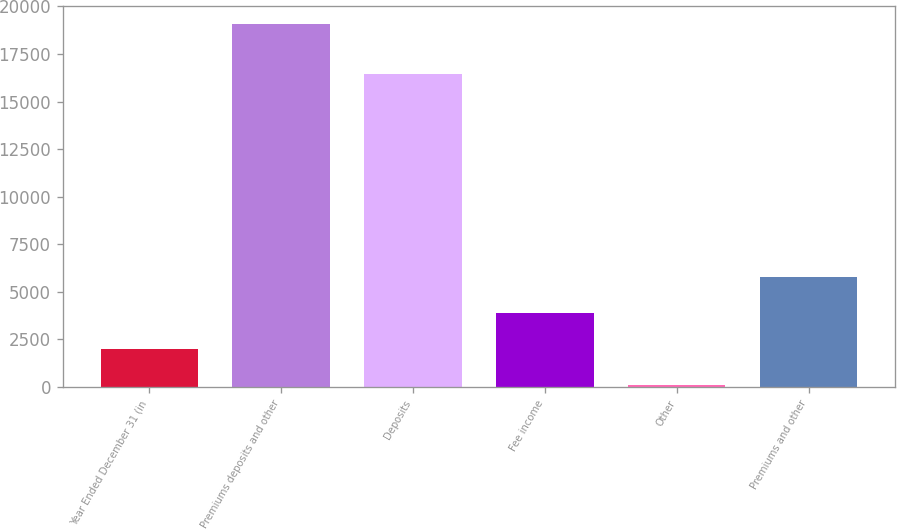<chart> <loc_0><loc_0><loc_500><loc_500><bar_chart><fcel>Year Ended December 31 (in<fcel>Premiums deposits and other<fcel>Deposits<fcel>Fee income<fcel>Other<fcel>Premiums and other<nl><fcel>2010<fcel>19086<fcel>16461<fcel>3908.1<fcel>105<fcel>5806.2<nl></chart> 